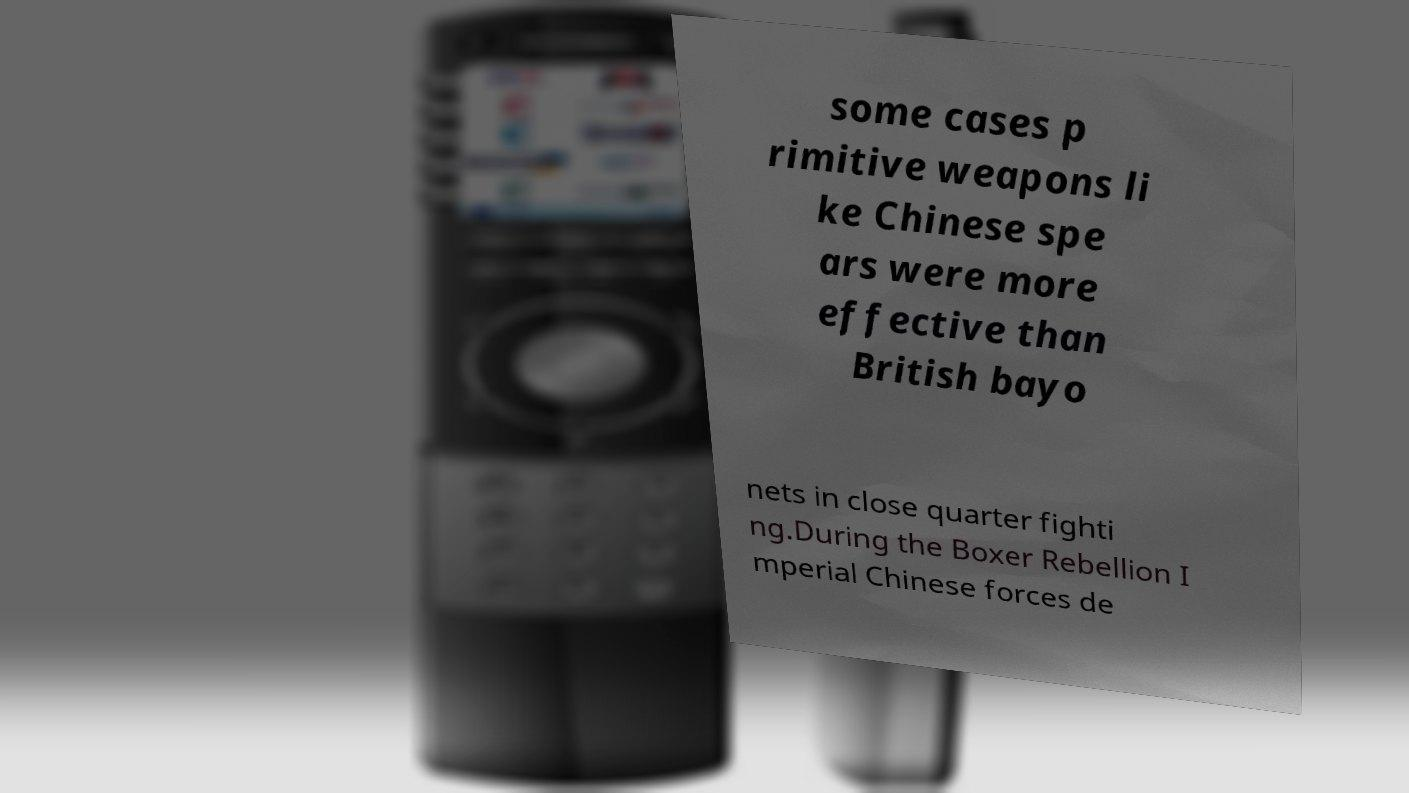I need the written content from this picture converted into text. Can you do that? some cases p rimitive weapons li ke Chinese spe ars were more effective than British bayo nets in close quarter fighti ng.During the Boxer Rebellion I mperial Chinese forces de 